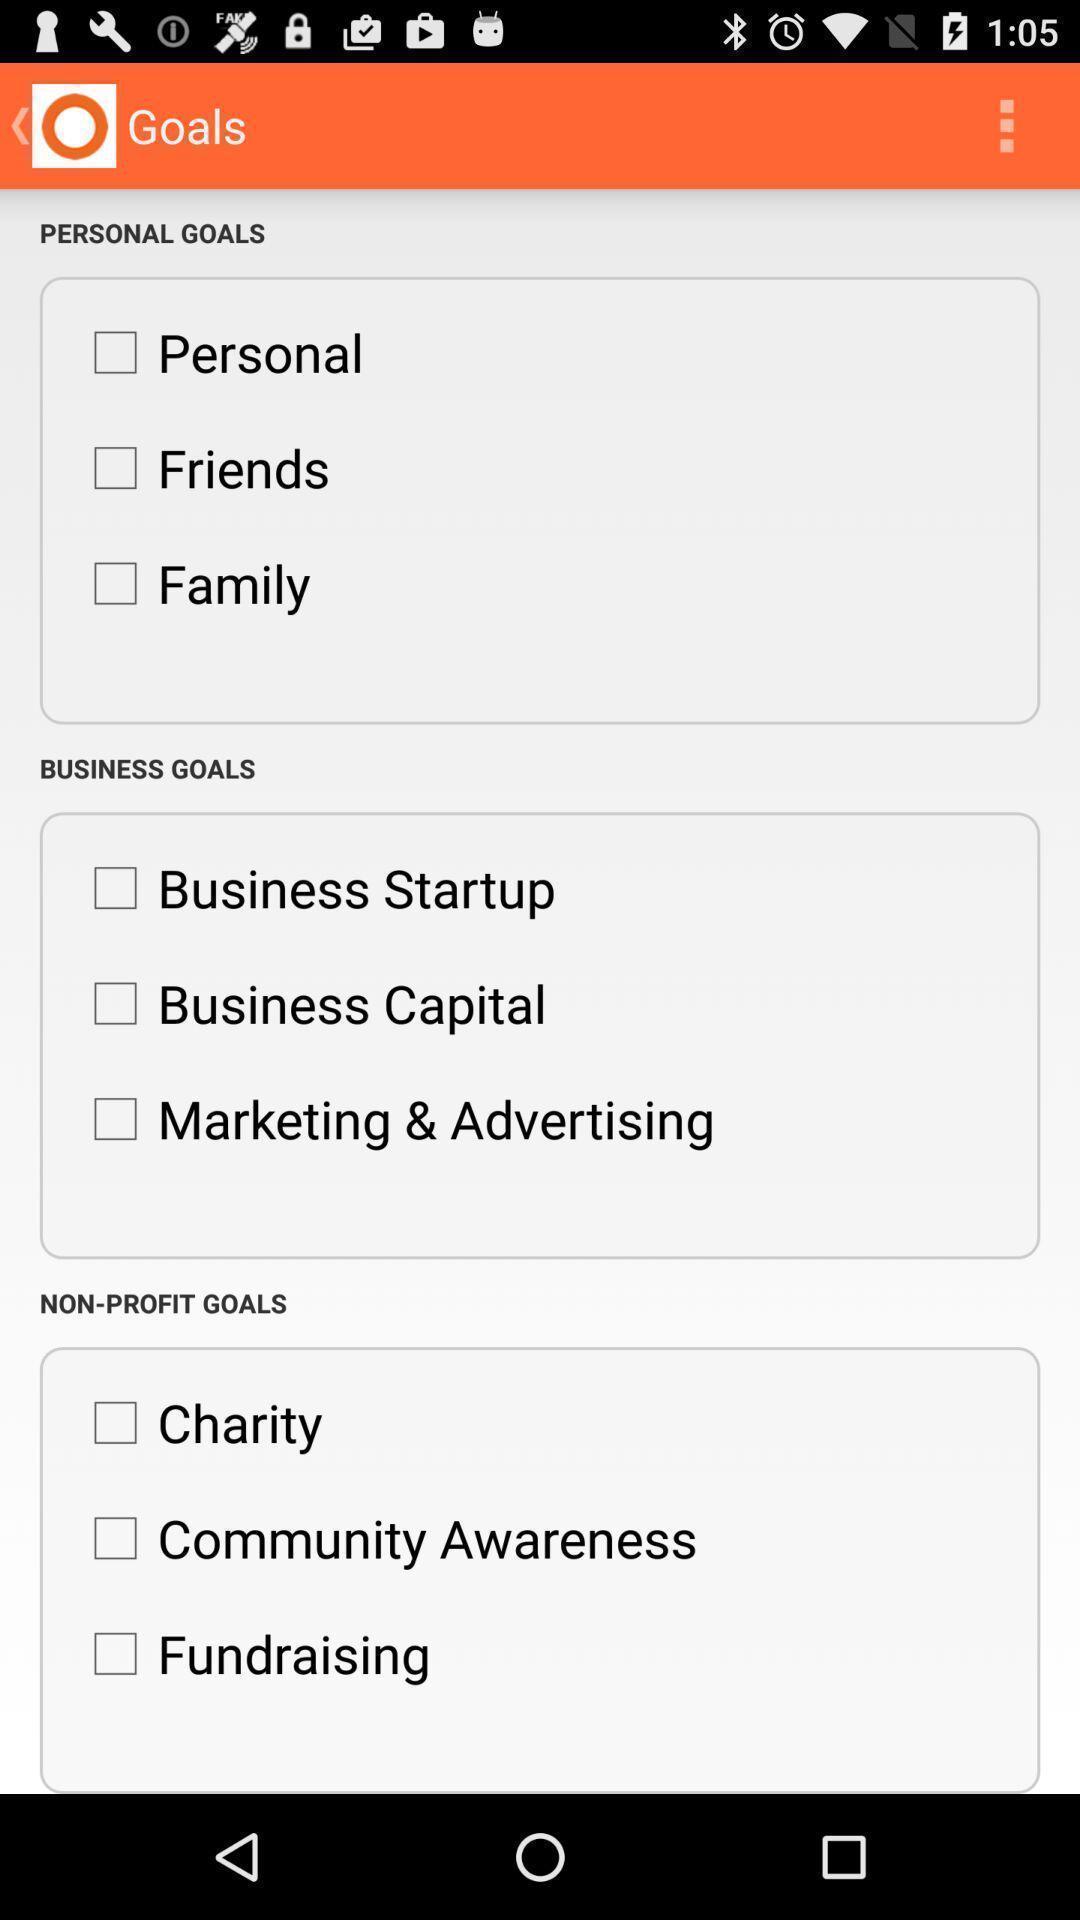What can you discern from this picture? Page showing goals in app. 